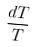Convert formula to latex. <formula><loc_0><loc_0><loc_500><loc_500>\frac { d T } { T }</formula> 